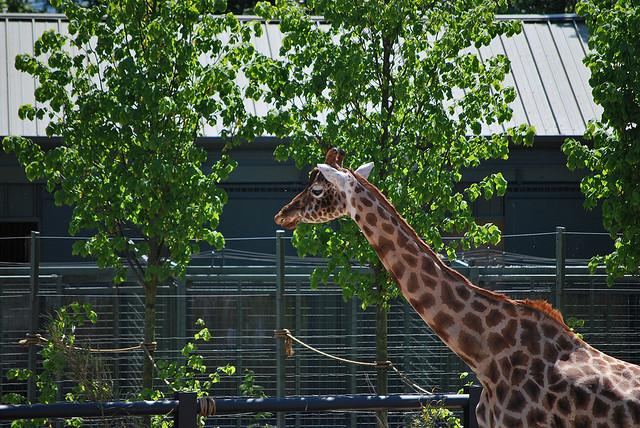What keeps the giraffe penned in?
Give a very brief answer. Fence. Does one of the fence posts in the background rise at least up to the shorter giraffe's throat?
Be succinct. Yes. What direction of the frame is the giraffe facing?
Answer briefly. Left. What are giraffes known for?
Be succinct. Long necks. 